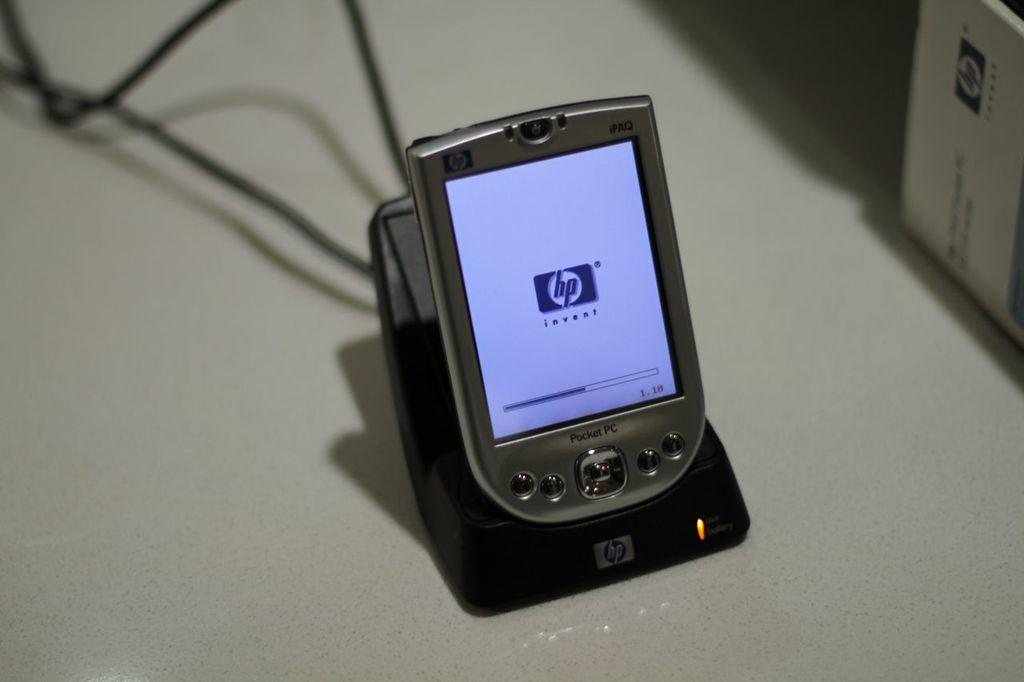What brand of palm is this?
Your response must be concise. Hp. Is this a pocket pc?
Give a very brief answer. Yes. 